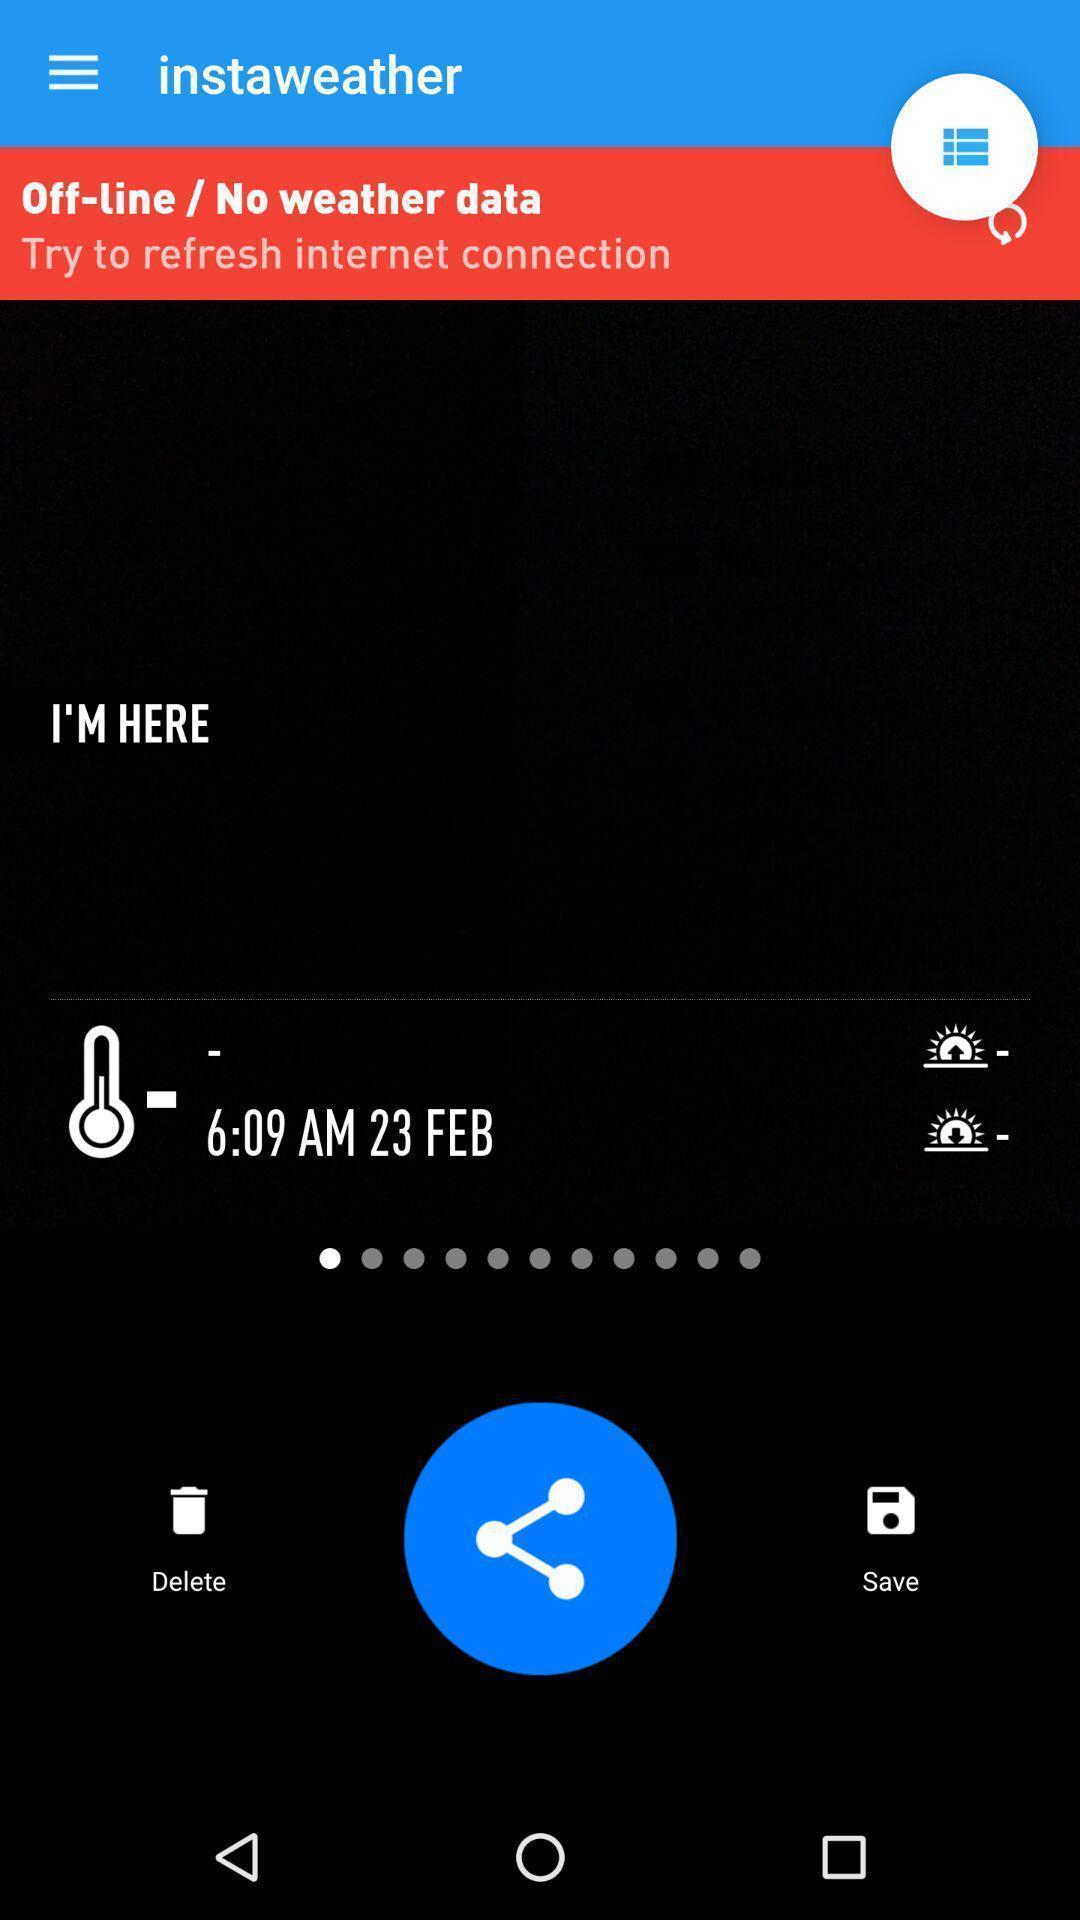Provide a textual representation of this image. Weather forecasting app showing weather report. 